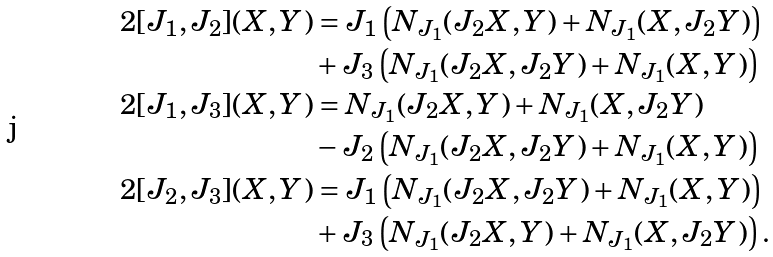<formula> <loc_0><loc_0><loc_500><loc_500>2 [ J _ { 1 } , J _ { 2 } ] ( X , Y ) & = J _ { 1 } \left ( N _ { J _ { 1 } } ( J _ { 2 } X , Y ) + N _ { J _ { 1 } } ( X , J _ { 2 } Y ) \right ) \\ & + J _ { 3 } \left ( N _ { J _ { 1 } } ( J _ { 2 } X , J _ { 2 } Y ) + N _ { J _ { 1 } } ( X , Y ) \right ) \\ 2 [ J _ { 1 } , J _ { 3 } ] ( X , Y ) & = N _ { J _ { 1 } } ( J _ { 2 } X , Y ) + N _ { J _ { 1 } } ( X , J _ { 2 } Y ) \\ & - J _ { 2 } \left ( N _ { J _ { 1 } } ( J _ { 2 } X , J _ { 2 } Y ) + N _ { J _ { 1 } } ( X , Y ) \right ) \\ 2 [ J _ { 2 } , J _ { 3 } ] ( X , Y ) & = J _ { 1 } \left ( N _ { J _ { 1 } } ( J _ { 2 } X , J _ { 2 } Y ) + N _ { J _ { 1 } } ( X , Y ) \right ) \\ & + J _ { 3 } \left ( N _ { J _ { 1 } } ( J _ { 2 } X , Y ) + N _ { J _ { 1 } } ( X , J _ { 2 } Y ) \right ) .</formula> 